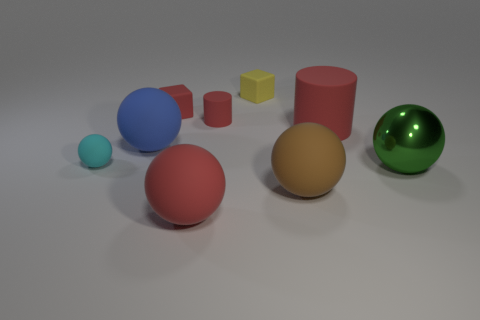What is the material of the green thing that is the same size as the blue ball?
Provide a succinct answer. Metal. There is a red cylinder right of the matte cylinder that is behind the large cylinder; how big is it?
Give a very brief answer. Large. There is a matte thing that is left of the blue object; is its size the same as the small red rubber block?
Make the answer very short. Yes. Is the number of red things behind the green metal thing greater than the number of yellow things in front of the tiny rubber cylinder?
Offer a terse response. Yes. There is a big matte object that is both to the left of the big brown object and to the right of the blue matte ball; what shape is it?
Your answer should be very brief. Sphere. What is the shape of the large matte object that is left of the small red rubber cube?
Your answer should be compact. Sphere. What is the size of the rubber block to the left of the red rubber object that is in front of the blue rubber sphere that is on the left side of the large brown matte ball?
Your answer should be compact. Small. Does the yellow rubber object have the same shape as the green shiny object?
Your answer should be very brief. No. There is a red object that is left of the tiny cylinder and behind the small cyan object; what size is it?
Give a very brief answer. Small. What is the material of the green thing that is the same shape as the brown thing?
Offer a terse response. Metal. 